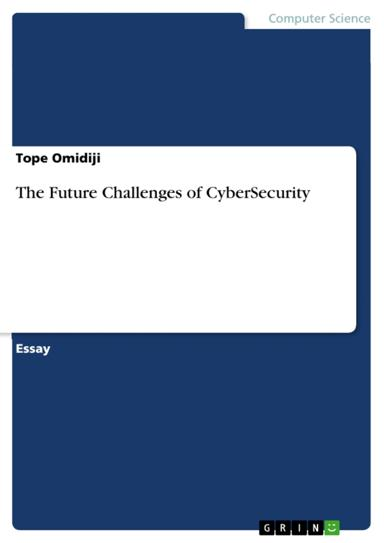What can be inferred about the author's perspective on cybersecurity? While it's challenging to ascertain the author's full perspective from the title alone, "The Future Challenges of CyberSecurity" implies a forward-thinking and perhaps cautionary stance. The author likely advocates for ongoing vigilance, adaptation to new threats, and continuous investment in security measures to safeguard against future vulnerabilities. 